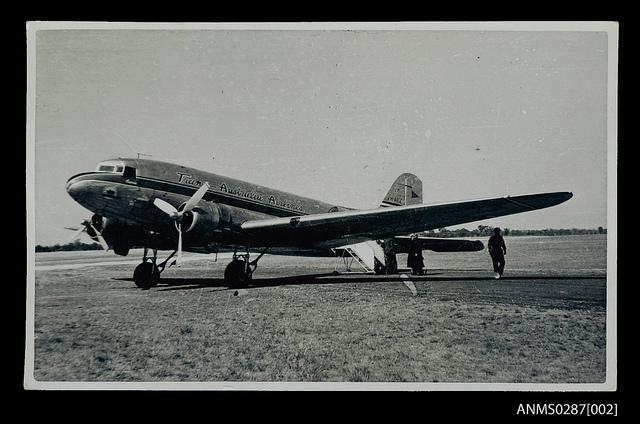Is the plane inside or outside?
Give a very brief answer. Outside. Is this a new airplane?
Keep it brief. No. What is the number at the bottom of the photo?
Short answer required. 002. How will the passengers board the plane?
Write a very short answer. Stairs. 